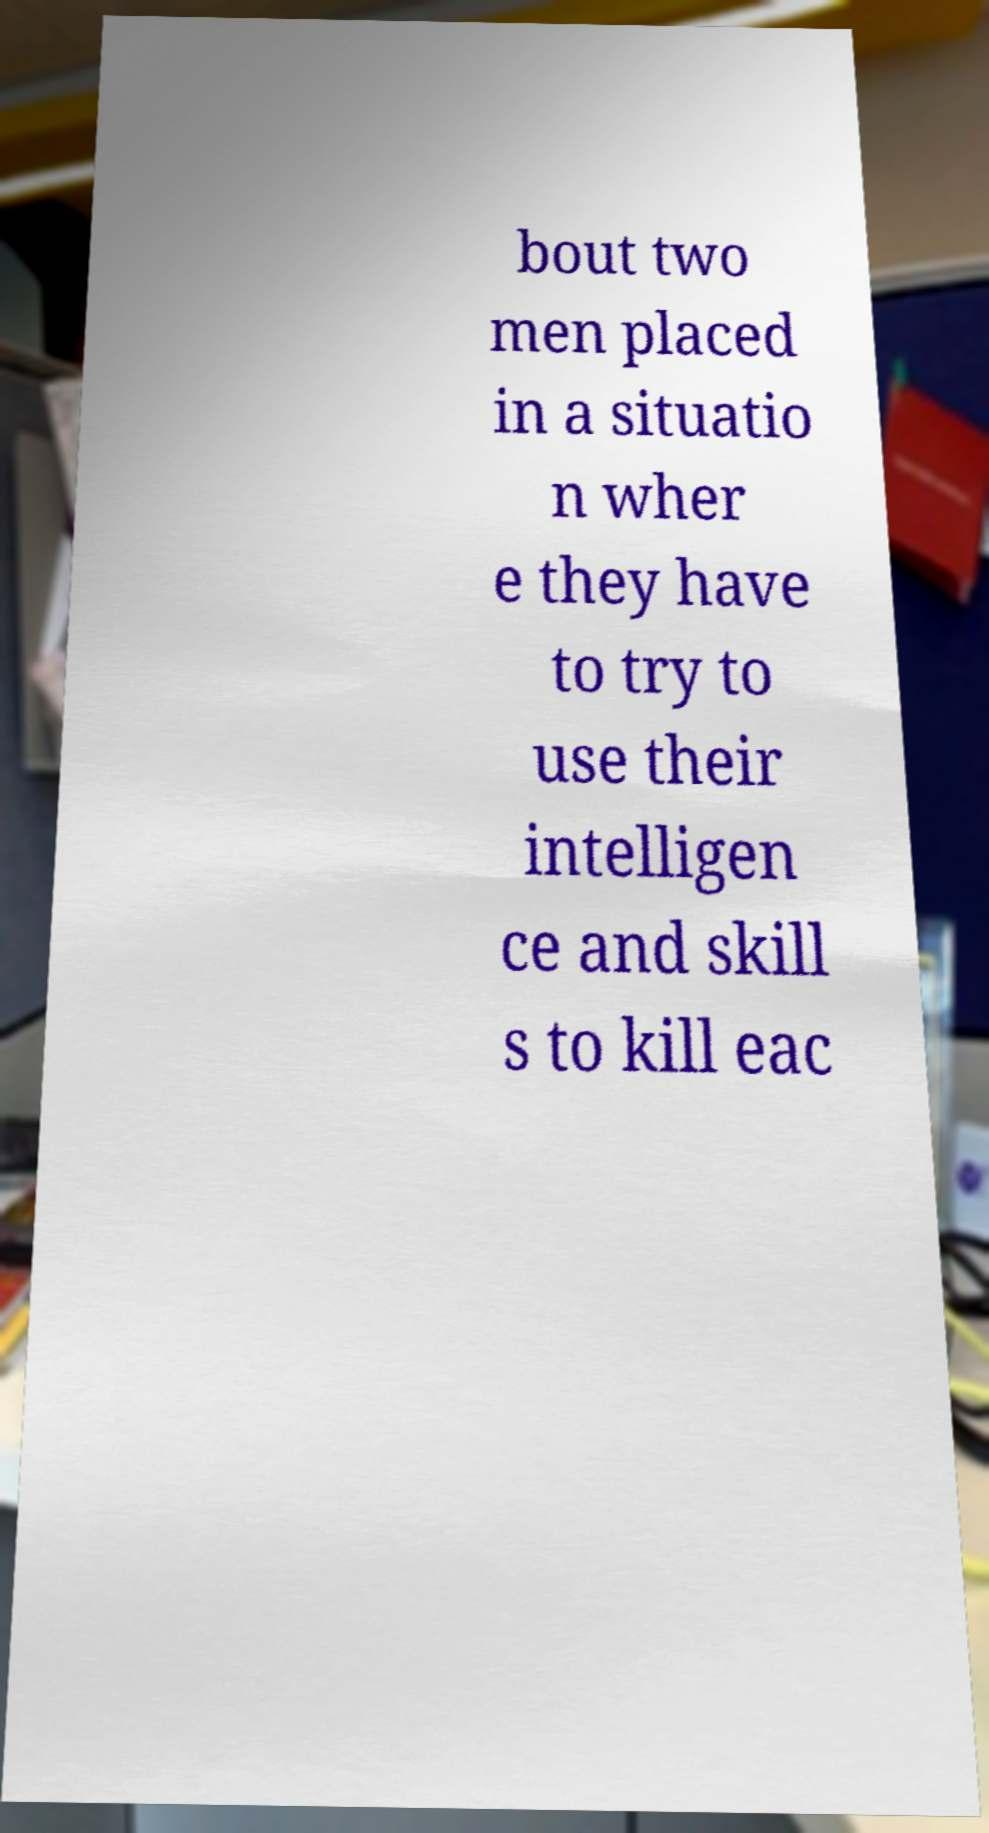What messages or text are displayed in this image? I need them in a readable, typed format. bout two men placed in a situatio n wher e they have to try to use their intelligen ce and skill s to kill eac 